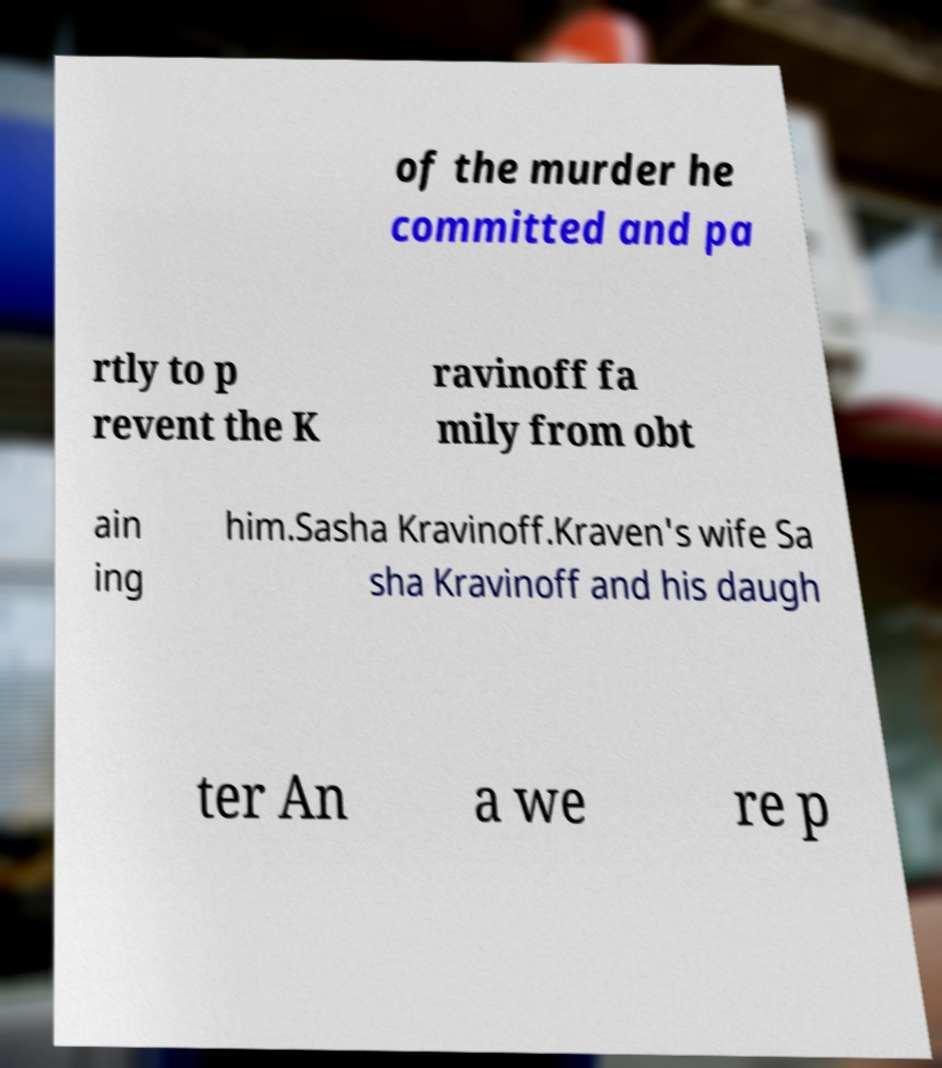Could you assist in decoding the text presented in this image and type it out clearly? of the murder he committed and pa rtly to p revent the K ravinoff fa mily from obt ain ing him.Sasha Kravinoff.Kraven's wife Sa sha Kravinoff and his daugh ter An a we re p 